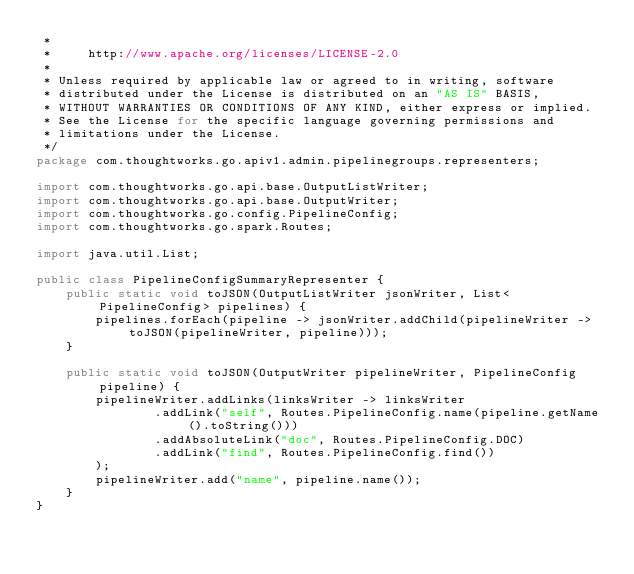<code> <loc_0><loc_0><loc_500><loc_500><_Java_> *
 *     http://www.apache.org/licenses/LICENSE-2.0
 *
 * Unless required by applicable law or agreed to in writing, software
 * distributed under the License is distributed on an "AS IS" BASIS,
 * WITHOUT WARRANTIES OR CONDITIONS OF ANY KIND, either express or implied.
 * See the License for the specific language governing permissions and
 * limitations under the License.
 */
package com.thoughtworks.go.apiv1.admin.pipelinegroups.representers;

import com.thoughtworks.go.api.base.OutputListWriter;
import com.thoughtworks.go.api.base.OutputWriter;
import com.thoughtworks.go.config.PipelineConfig;
import com.thoughtworks.go.spark.Routes;

import java.util.List;

public class PipelineConfigSummaryRepresenter {
    public static void toJSON(OutputListWriter jsonWriter, List<PipelineConfig> pipelines) {
        pipelines.forEach(pipeline -> jsonWriter.addChild(pipelineWriter -> toJSON(pipelineWriter, pipeline)));
    }

    public static void toJSON(OutputWriter pipelineWriter, PipelineConfig pipeline) {
        pipelineWriter.addLinks(linksWriter -> linksWriter
                .addLink("self", Routes.PipelineConfig.name(pipeline.getName().toString()))
                .addAbsoluteLink("doc", Routes.PipelineConfig.DOC)
                .addLink("find", Routes.PipelineConfig.find())
        );
        pipelineWriter.add("name", pipeline.name());
    }
}
</code> 